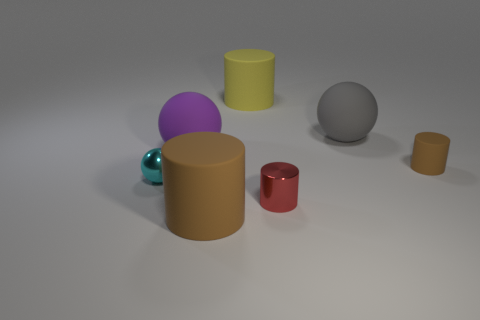There is a big brown thing that is the same material as the large yellow object; what is its shape?
Your answer should be very brief. Cylinder. Is the small metal sphere the same color as the tiny matte cylinder?
Offer a terse response. No. Is the material of the brown cylinder to the left of the small brown rubber thing the same as the tiny brown object behind the cyan thing?
Offer a terse response. Yes. What number of objects are tiny red shiny cylinders or matte cylinders that are in front of the small cyan metal sphere?
Give a very brief answer. 2. Is there anything else that is the same material as the yellow thing?
Offer a terse response. Yes. What is the shape of the other object that is the same color as the tiny rubber object?
Your response must be concise. Cylinder. What material is the red thing?
Your response must be concise. Metal. Is the material of the gray thing the same as the small brown thing?
Ensure brevity in your answer.  Yes. What number of rubber objects are large brown cylinders or brown things?
Make the answer very short. 2. There is a brown rubber thing left of the large yellow cylinder; what is its shape?
Provide a short and direct response. Cylinder. 